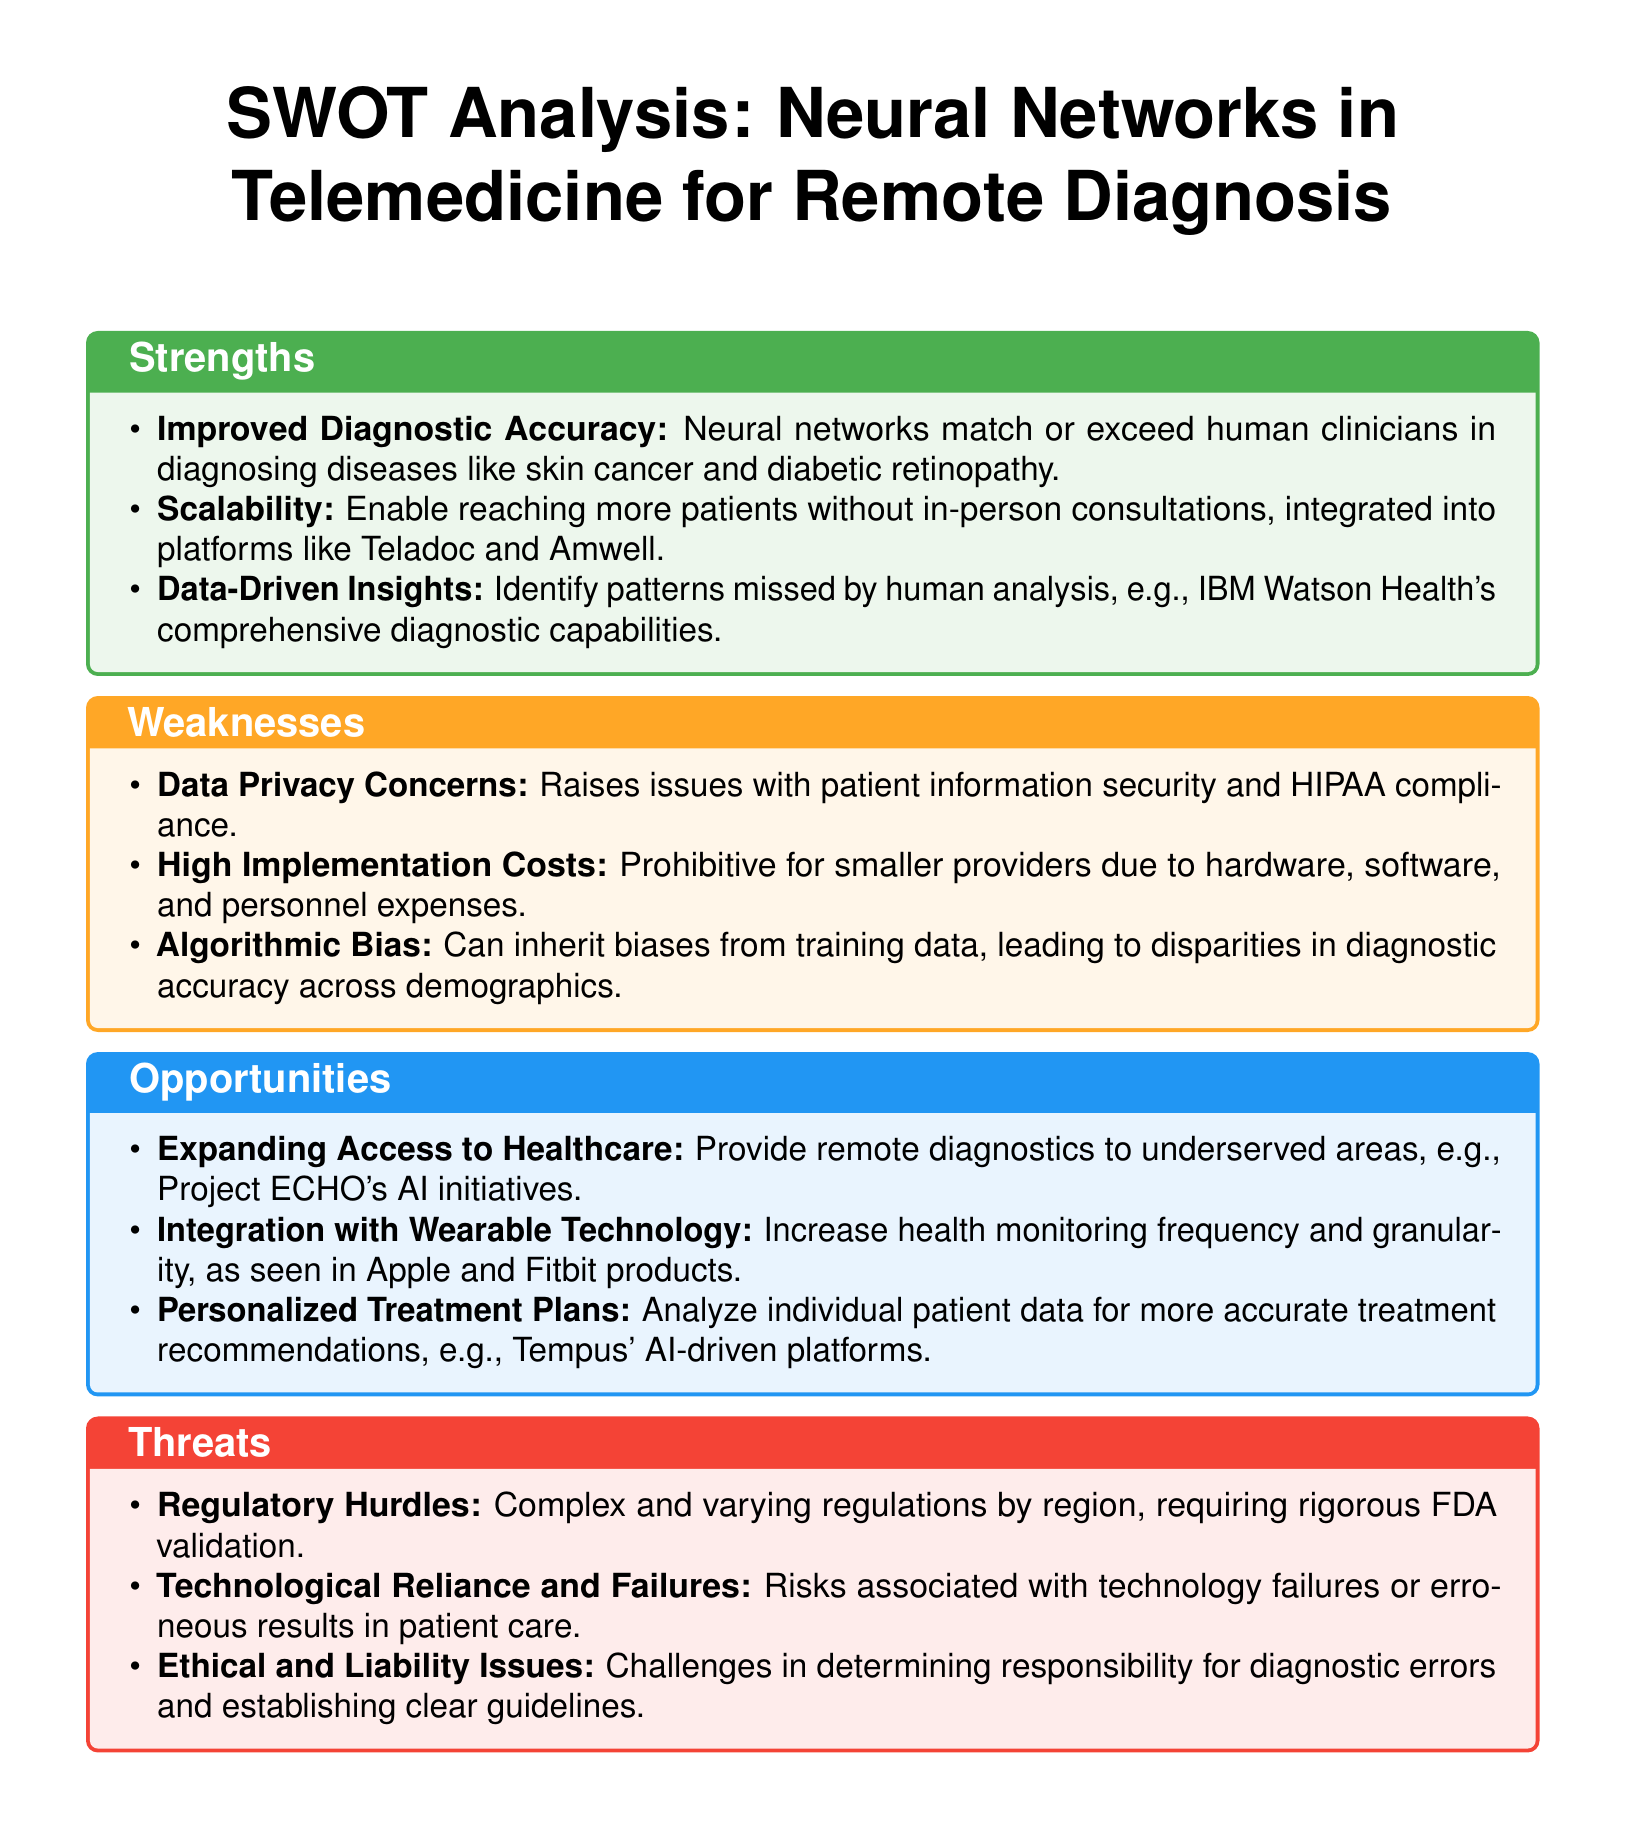What is one strength of neural networks in telemedicine? The document lists "Improved Diagnostic Accuracy" as a strength, meaning neural networks match or exceed human clinicians in diagnosing diseases.
Answer: Improved Diagnostic Accuracy What is a weakness associated with the implementation of neural networks? One of the weaknesses highlighted is "High Implementation Costs," which might be prohibitive for smaller providers.
Answer: High Implementation Costs How many opportunities for neural networks in telemedicine are mentioned? The document lists three opportunities under the Opportunities section.
Answer: 3 What can algorithmic bias lead to? Algorithmic bias can lead to disparities in diagnostic accuracy across demographics.
Answer: Disparities in diagnostic accuracy What major regulatory concern is noted as a threat? The document identifies "Regulatory Hurdles" as a key threat that involves complex and varying regulations.
Answer: Regulatory Hurdles What technology integration is mentioned as an opportunity? The document discusses "Integration with Wearable Technology" as one of the opportunities.
Answer: Integration with Wearable Technology What potential risk is associated with technology reliance in this context? The document notes "Technological Reliance and Failures" as a threat, indicating risks from technology failures.
Answer: Technological Reliance and Failures What is a potential ethical challenge mentioned in the document? Ethical and liability issues represent challenges in determining responsibility for diagnostic errors.
Answer: Ethical and liability issues 